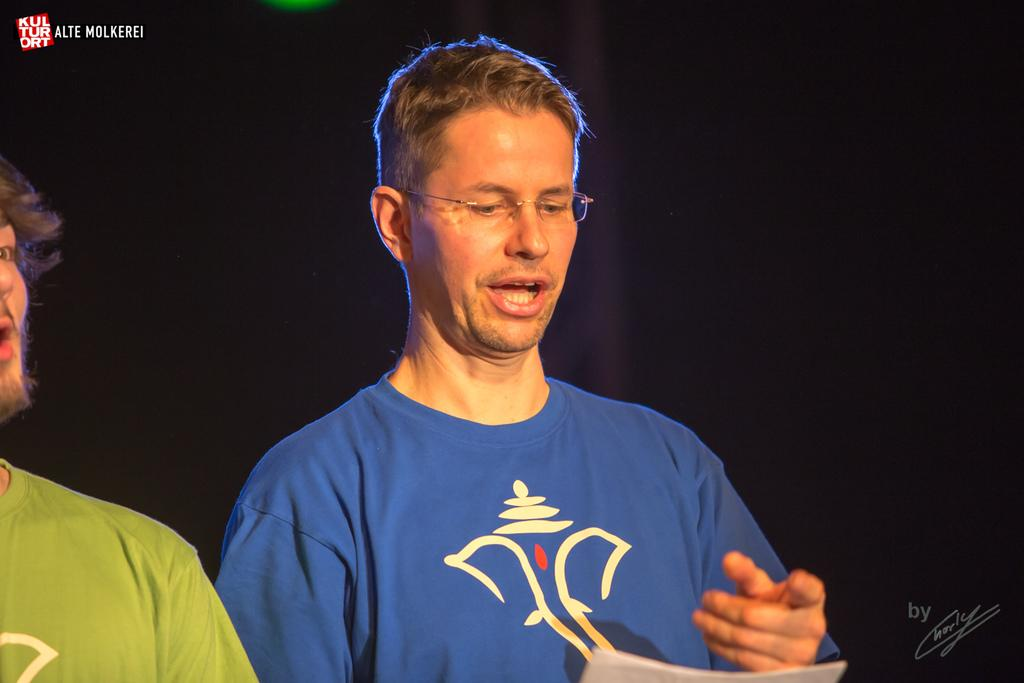How many people are in the image? There are two persons in the image. Can you describe one of the persons in the image? One of the persons is wearing spectacles. What can be observed about the background of the image? The background of the image is dark. What type of thread is being used by the person in the image to express their opinion? There is no thread or expression of opinion present in the image; it only features two persons and a dark background. 